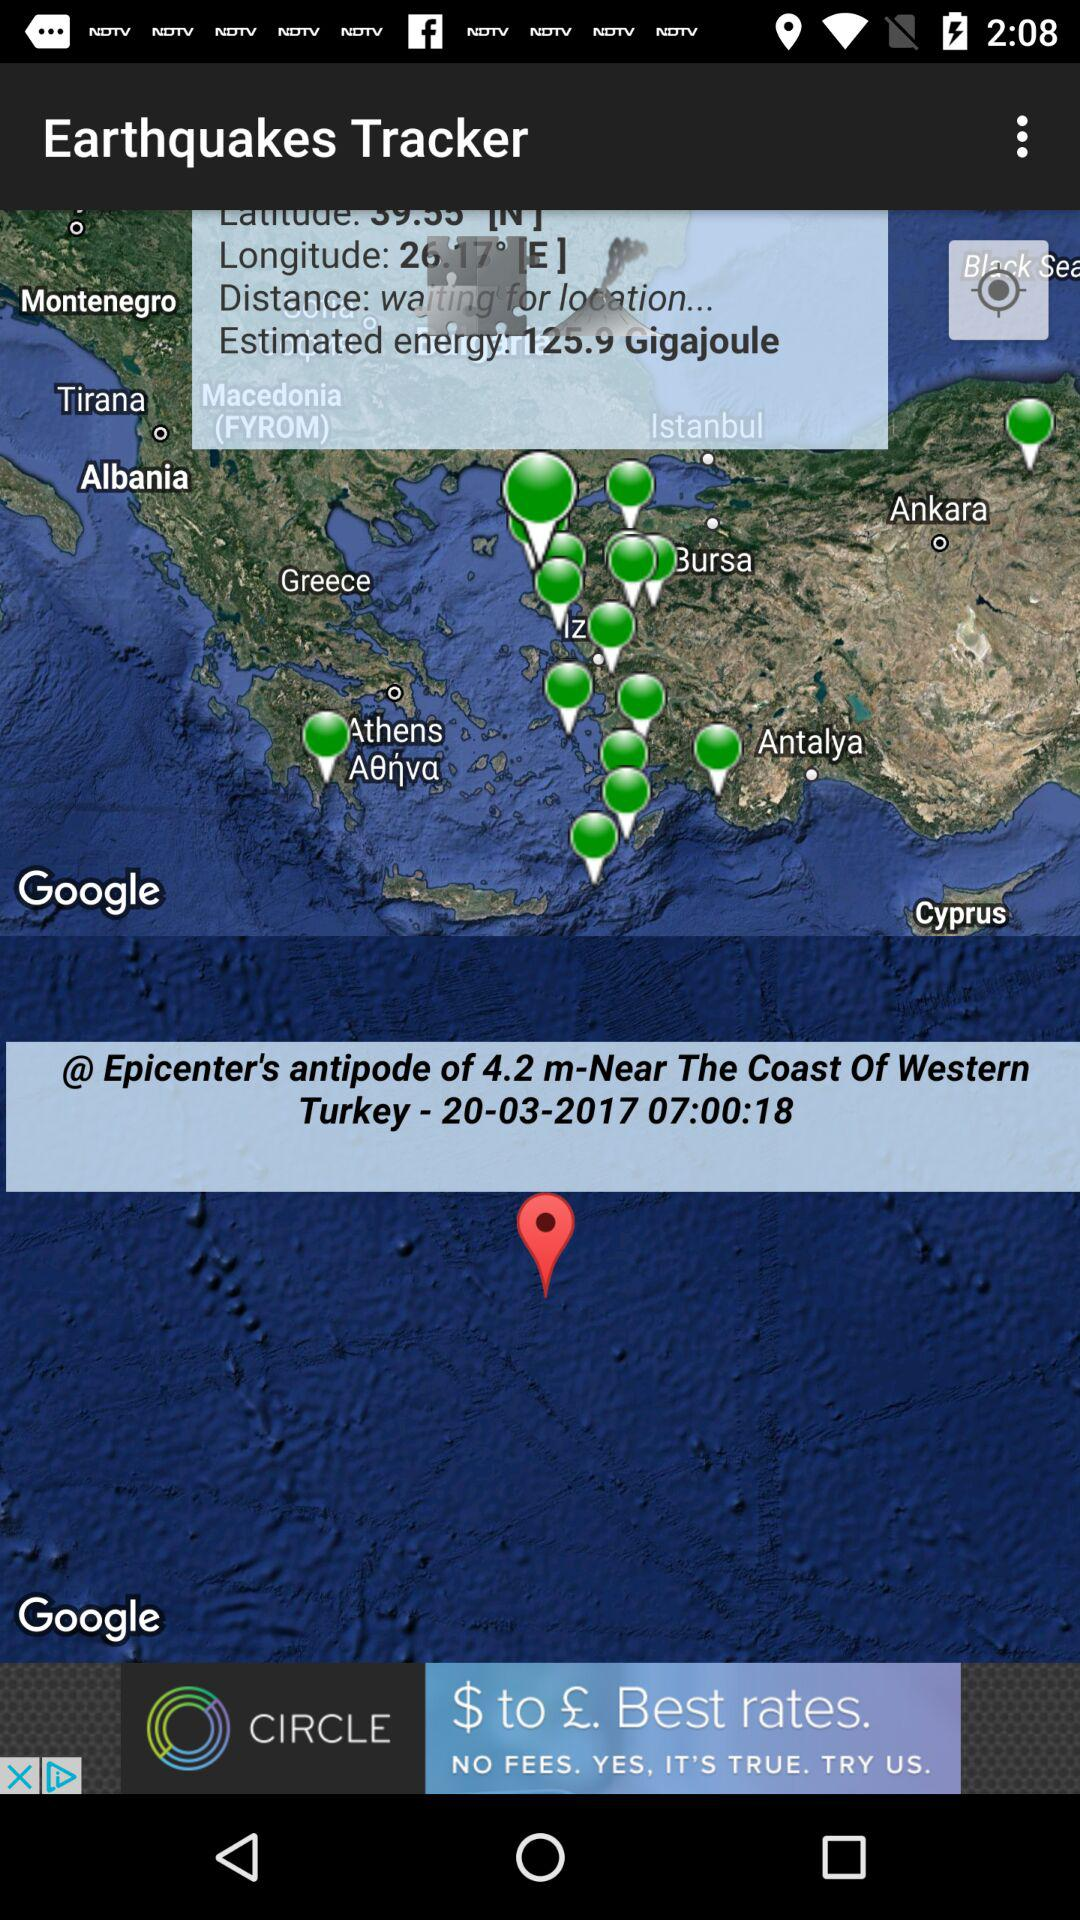What is the Turkey Time? The Turkey Time is 07:00:18. 